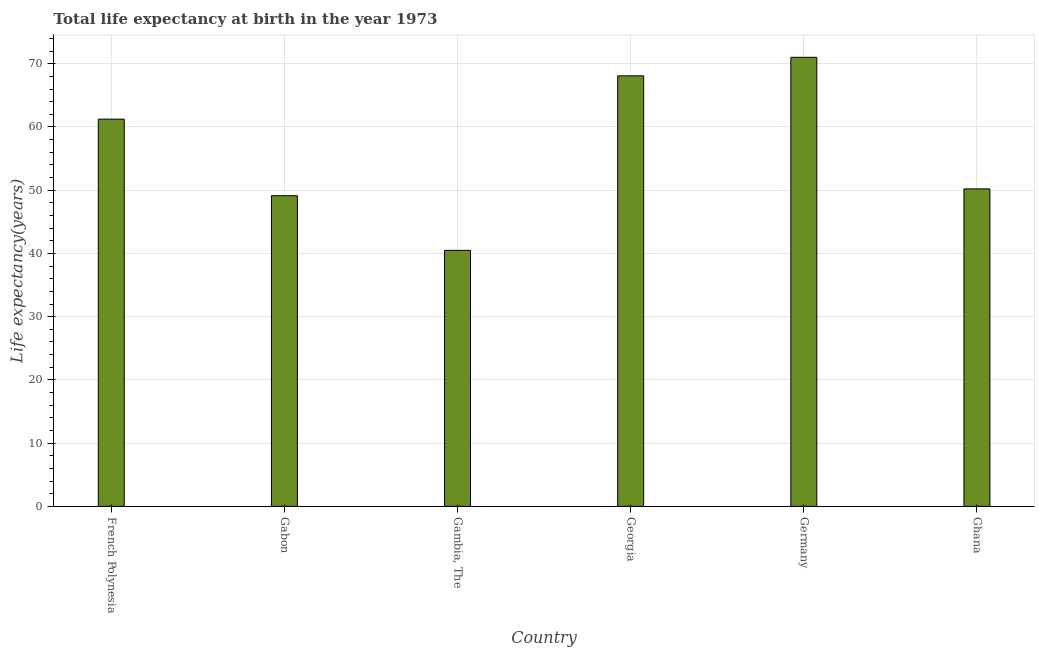Does the graph contain grids?
Your answer should be compact. Yes. What is the title of the graph?
Make the answer very short. Total life expectancy at birth in the year 1973. What is the label or title of the X-axis?
Offer a very short reply. Country. What is the label or title of the Y-axis?
Your response must be concise. Life expectancy(years). What is the life expectancy at birth in Gabon?
Ensure brevity in your answer.  49.13. Across all countries, what is the maximum life expectancy at birth?
Your answer should be very brief. 71.02. Across all countries, what is the minimum life expectancy at birth?
Give a very brief answer. 40.49. In which country was the life expectancy at birth minimum?
Provide a succinct answer. Gambia, The. What is the sum of the life expectancy at birth?
Make the answer very short. 340.18. What is the difference between the life expectancy at birth in Gambia, The and Ghana?
Give a very brief answer. -9.72. What is the average life expectancy at birth per country?
Your answer should be very brief. 56.7. What is the median life expectancy at birth?
Provide a succinct answer. 55.72. In how many countries, is the life expectancy at birth greater than 44 years?
Your answer should be very brief. 5. What is the ratio of the life expectancy at birth in Gambia, The to that in Ghana?
Keep it short and to the point. 0.81. Is the difference between the life expectancy at birth in Germany and Ghana greater than the difference between any two countries?
Ensure brevity in your answer.  No. What is the difference between the highest and the second highest life expectancy at birth?
Provide a succinct answer. 2.93. Is the sum of the life expectancy at birth in Gambia, The and Ghana greater than the maximum life expectancy at birth across all countries?
Keep it short and to the point. Yes. What is the difference between the highest and the lowest life expectancy at birth?
Provide a short and direct response. 30.53. In how many countries, is the life expectancy at birth greater than the average life expectancy at birth taken over all countries?
Make the answer very short. 3. Are the values on the major ticks of Y-axis written in scientific E-notation?
Give a very brief answer. No. What is the Life expectancy(years) in French Polynesia?
Provide a succinct answer. 61.24. What is the Life expectancy(years) in Gabon?
Ensure brevity in your answer.  49.13. What is the Life expectancy(years) of Gambia, The?
Offer a terse response. 40.49. What is the Life expectancy(years) in Georgia?
Your answer should be very brief. 68.09. What is the Life expectancy(years) in Germany?
Your answer should be compact. 71.02. What is the Life expectancy(years) in Ghana?
Offer a terse response. 50.21. What is the difference between the Life expectancy(years) in French Polynesia and Gabon?
Offer a very short reply. 12.1. What is the difference between the Life expectancy(years) in French Polynesia and Gambia, The?
Give a very brief answer. 20.75. What is the difference between the Life expectancy(years) in French Polynesia and Georgia?
Make the answer very short. -6.85. What is the difference between the Life expectancy(years) in French Polynesia and Germany?
Your answer should be compact. -9.78. What is the difference between the Life expectancy(years) in French Polynesia and Ghana?
Offer a terse response. 11.03. What is the difference between the Life expectancy(years) in Gabon and Gambia, The?
Keep it short and to the point. 8.64. What is the difference between the Life expectancy(years) in Gabon and Georgia?
Provide a succinct answer. -18.96. What is the difference between the Life expectancy(years) in Gabon and Germany?
Offer a very short reply. -21.88. What is the difference between the Life expectancy(years) in Gabon and Ghana?
Ensure brevity in your answer.  -1.07. What is the difference between the Life expectancy(years) in Gambia, The and Georgia?
Provide a short and direct response. -27.6. What is the difference between the Life expectancy(years) in Gambia, The and Germany?
Offer a terse response. -30.53. What is the difference between the Life expectancy(years) in Gambia, The and Ghana?
Your answer should be very brief. -9.72. What is the difference between the Life expectancy(years) in Georgia and Germany?
Your response must be concise. -2.93. What is the difference between the Life expectancy(years) in Georgia and Ghana?
Your answer should be compact. 17.88. What is the difference between the Life expectancy(years) in Germany and Ghana?
Offer a terse response. 20.81. What is the ratio of the Life expectancy(years) in French Polynesia to that in Gabon?
Your response must be concise. 1.25. What is the ratio of the Life expectancy(years) in French Polynesia to that in Gambia, The?
Make the answer very short. 1.51. What is the ratio of the Life expectancy(years) in French Polynesia to that in Georgia?
Your response must be concise. 0.9. What is the ratio of the Life expectancy(years) in French Polynesia to that in Germany?
Ensure brevity in your answer.  0.86. What is the ratio of the Life expectancy(years) in French Polynesia to that in Ghana?
Give a very brief answer. 1.22. What is the ratio of the Life expectancy(years) in Gabon to that in Gambia, The?
Give a very brief answer. 1.21. What is the ratio of the Life expectancy(years) in Gabon to that in Georgia?
Ensure brevity in your answer.  0.72. What is the ratio of the Life expectancy(years) in Gabon to that in Germany?
Give a very brief answer. 0.69. What is the ratio of the Life expectancy(years) in Gambia, The to that in Georgia?
Offer a very short reply. 0.59. What is the ratio of the Life expectancy(years) in Gambia, The to that in Germany?
Provide a succinct answer. 0.57. What is the ratio of the Life expectancy(years) in Gambia, The to that in Ghana?
Make the answer very short. 0.81. What is the ratio of the Life expectancy(years) in Georgia to that in Ghana?
Ensure brevity in your answer.  1.36. What is the ratio of the Life expectancy(years) in Germany to that in Ghana?
Give a very brief answer. 1.41. 